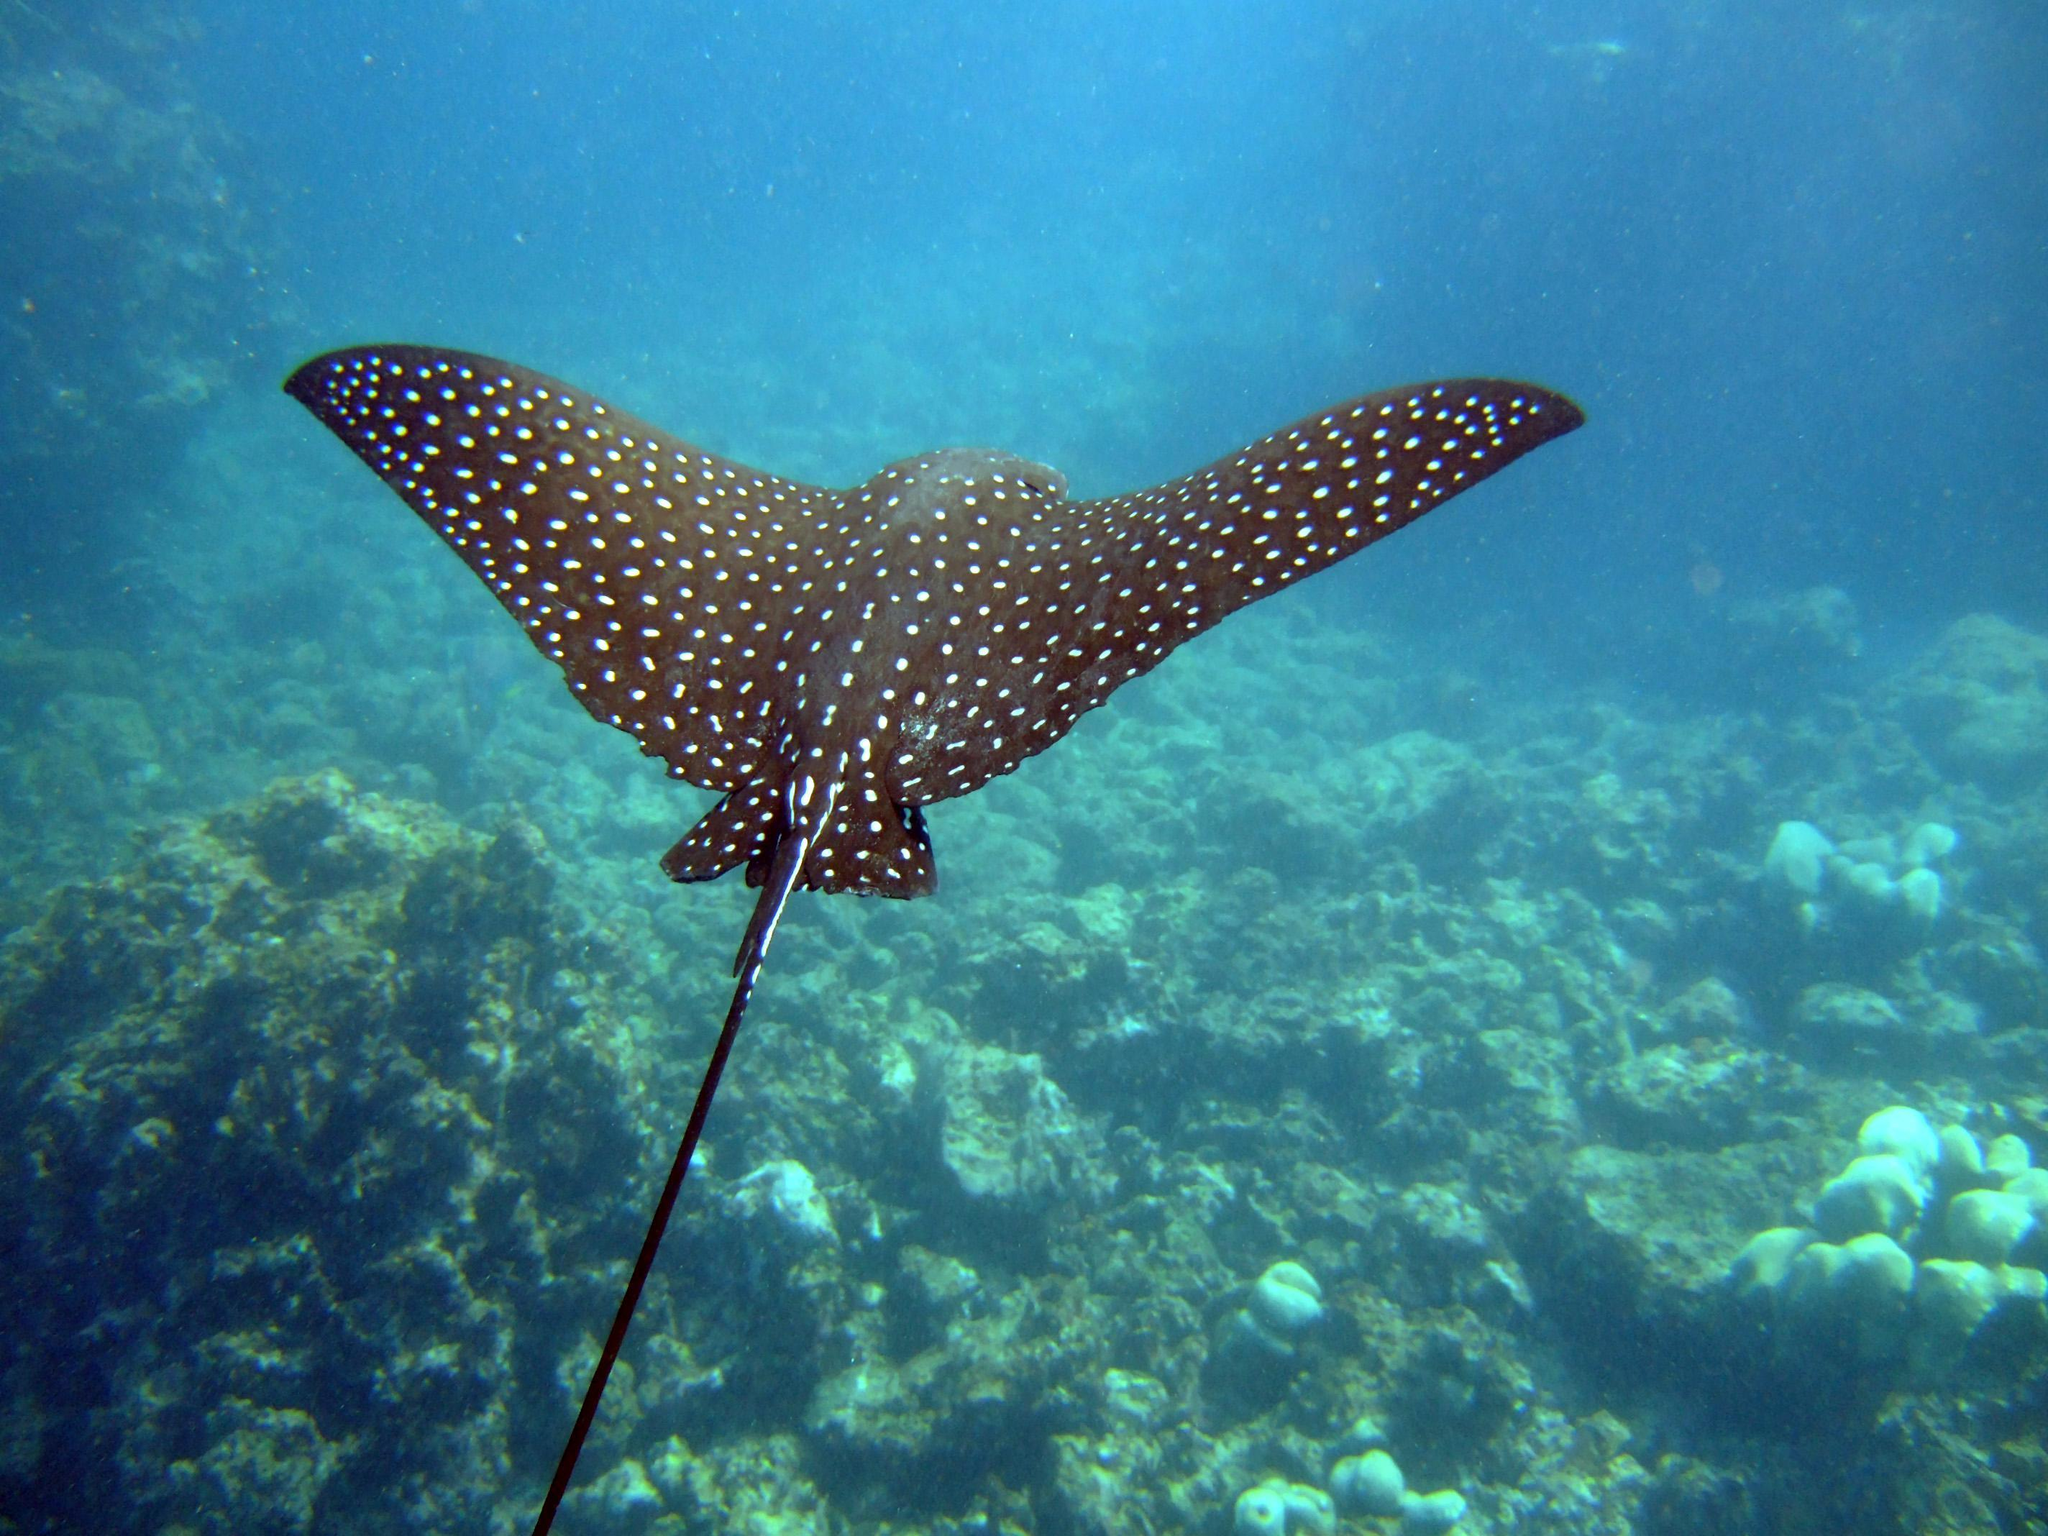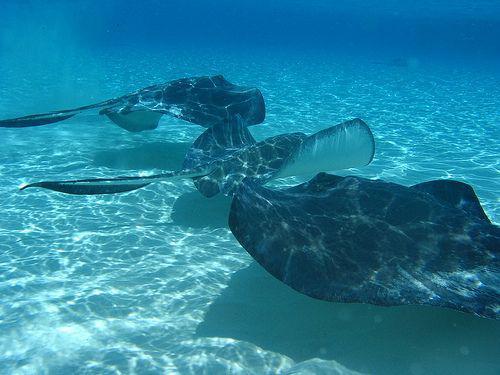The first image is the image on the left, the second image is the image on the right. Assess this claim about the two images: "There is one spotted eagle ray.". Correct or not? Answer yes or no. Yes. The first image is the image on the left, the second image is the image on the right. Examine the images to the left and right. Is the description "There are two stingrays and no other creatures." accurate? Answer yes or no. No. 